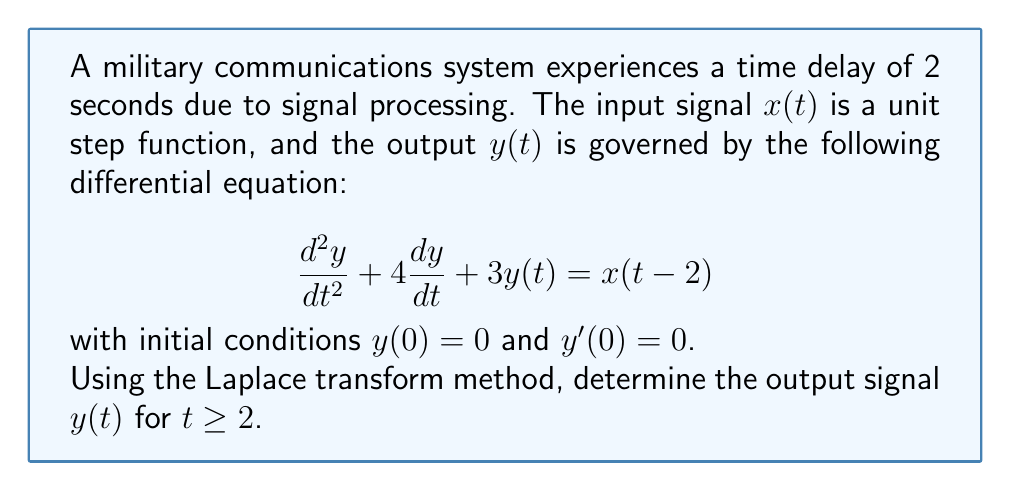Could you help me with this problem? Let's solve this problem step by step using the Laplace transform method:

1) First, we take the Laplace transform of both sides of the differential equation:

   $\mathcal{L}\{y''(t) + 4y'(t) + 3y(t)\} = \mathcal{L}\{x(t-2)\}$

2) Using the properties of Laplace transform:

   $(s^2Y(s) - sy(0) - y'(0)) + 4(sY(s) - y(0)) + 3Y(s) = e^{-2s}X(s)$

   where $Y(s) = \mathcal{L}\{y(t)\}$ and $X(s) = \mathcal{L}\{x(t)\}$

3) Substituting the initial conditions $y(0) = 0$ and $y'(0) = 0$:

   $s^2Y(s) + 4sY(s) + 3Y(s) = e^{-2s}X(s)$

4) Factor out $Y(s)$:

   $Y(s)(s^2 + 4s + 3) = e^{-2s}X(s)$

5) For a unit step input, $X(s) = \frac{1}{s}$. Substituting this:

   $Y(s)(s^2 + 4s + 3) = \frac{e^{-2s}}{s}$

6) Solve for $Y(s)$:

   $Y(s) = \frac{e^{-2s}}{s(s^2 + 4s + 3)}$

7) To find $y(t)$, we need to take the inverse Laplace transform. First, let's decompose the fraction:

   $Y(s) = \frac{e^{-2s}}{s(s+1)(s+3)}$

8) Using partial fraction decomposition:

   $Y(s) = e^{-2s}(\frac{A}{s} + \frac{B}{s+1} + \frac{C}{s+3})$

   where $A = \frac{1}{3}$, $B = -\frac{1}{2}$, and $C = \frac{1}{6}$

9) Now we can take the inverse Laplace transform:

   $y(t) = u(t-2)[\frac{1}{3} - \frac{1}{2}e^{-(t-2)} + \frac{1}{6}e^{-3(t-2)}]$

   where $u(t-2)$ is the unit step function shifted by 2 seconds.

This expression gives us $y(t)$ for $t \geq 2$. For $0 \leq t < 2$, $y(t) = 0$ due to the time delay.
Answer: $y(t) = \begin{cases} 
0 & \text{for } 0 \leq t < 2 \\
\frac{1}{3} - \frac{1}{2}e^{-(t-2)} + \frac{1}{6}e^{-3(t-2)} & \text{for } t \geq 2
\end{cases}$ 